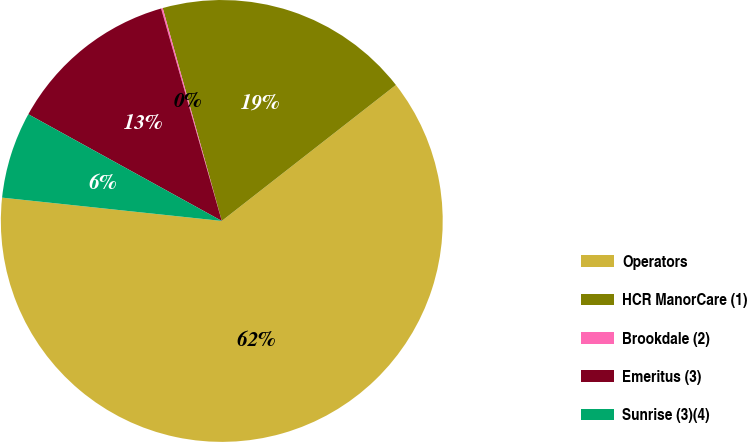Convert chart to OTSL. <chart><loc_0><loc_0><loc_500><loc_500><pie_chart><fcel>Operators<fcel>HCR ManorCare (1)<fcel>Brookdale (2)<fcel>Emeritus (3)<fcel>Sunrise (3)(4)<nl><fcel>62.24%<fcel>18.76%<fcel>0.12%<fcel>12.55%<fcel>6.34%<nl></chart> 